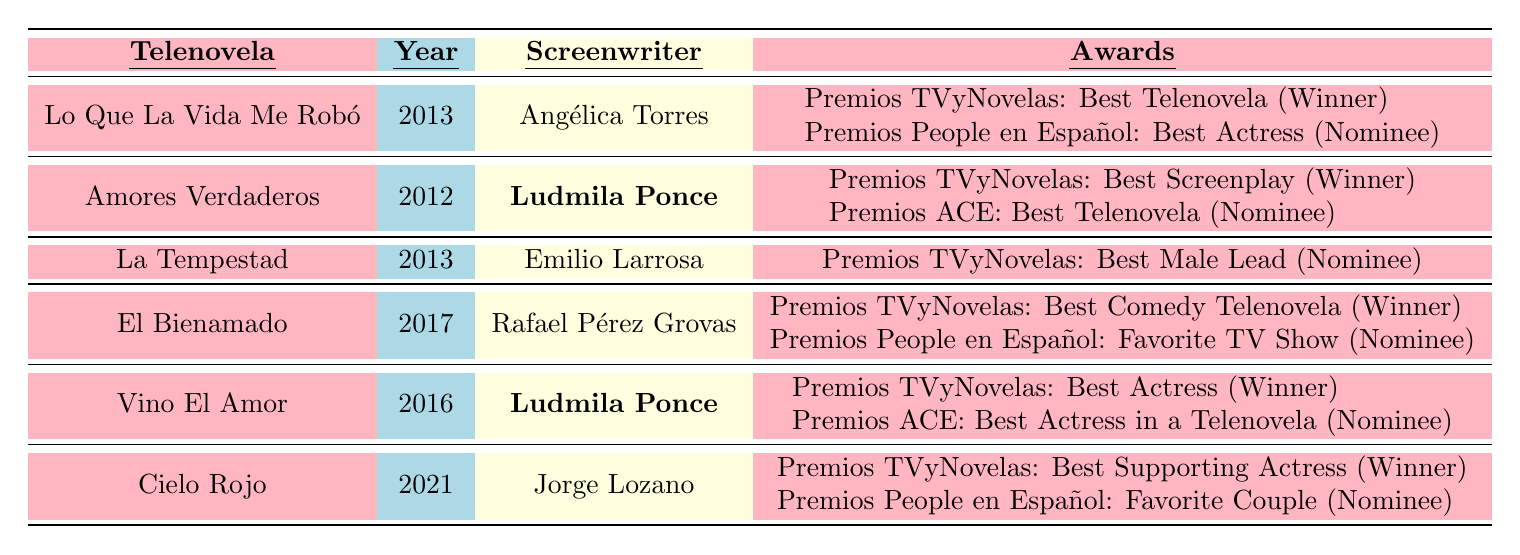What is the title of the telenovela written by Ludmila Ponce in 2012? According to the table, the telenovela titled "Amores Verdaderos" was written by Ludmila Ponce in 2012.
Answer: Amores Verdaderos How many awards did the telenovela "La Tempestad" receive? The table shows that "La Tempestad" received one nomination for the Premios TVyNovelas for Best Male Lead but did not win any awards.
Answer: 1 nomination Which telenovela won the Premios TVyNovelas for Best Comedy Telenovela? The table indicates that "El Bienamado," written by Rafael Pérez Grovas in 2017, won the Premios TVyNovelas for Best Comedy Telenovela.
Answer: El Bienamado Did "Vino El Amor" win the Premios ACE award? Based on the table, "Vino El Amor" received a nomination for the Premios ACE for Best Actress in a Telenovela, but it did not win. Therefore, the statement is false.
Answer: No Which telenovela had the most nominations listed? To determine this, we count the nominations: "Lo Que La Vida Me Robó" has 1, "Amores Verdaderos" has 1, "La Tempestad" has 1, "El Bienamado" has 1, "Vino El Amor" has 1, and "Cielo Rojo" has 1. All have 1 nomination, but "El Bienamado" has 2 total awards (1 win, 1 nomination), making it the telenovela with the most overall mentions.
Answer: El Bienamado How many different screenwriters are represented in the table? The screenwriters listed in the table are Angélica Torres, Ludmila Ponce, Emilio Larrosa, Rafael Pérez Grovas, and Jorge Lozano, totaling five different screenwriters.
Answer: 5 Was there any telenovela written by Ludmila Ponce that won an award? Yes, the table shows that "Amores Verdaderos," written by Ludmila Ponce, won the Premios TVyNovelas for Best Screenplay.
Answer: Yes Which year had the telenovela with the highest number of awards won? Looking at the table, "El Bienamado" (2017) won 1 award and "Vino El Amor" (2016) also has 1 win for Best Actress. All others had either one nomination or one win. Thus, both 2016 and 2017 had telenovelas with equal awards, but since 2017 has a higher overall mention (2), that makes it notable.
Answer: 2017 What is the total number of awards won by telenovelas written by Ludmila Ponce? "Amores Verdaderos" won 1 award (Best Screenplay) and "Vino El Amor" won 1 award (Best Actress), making a total of 2 awards won by telenovelas written by Ludmila Ponce.
Answer: 2 